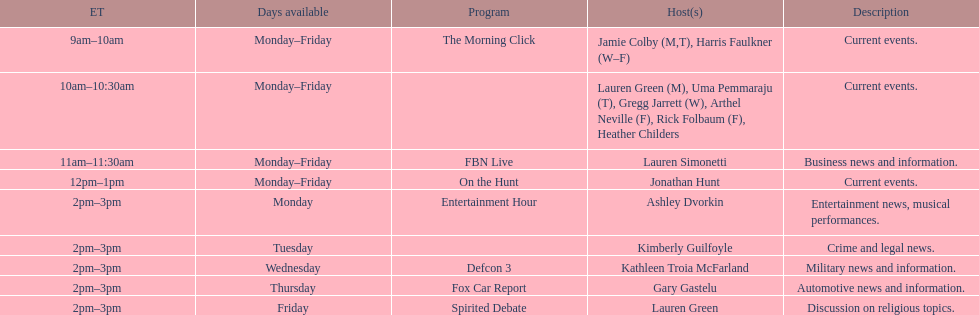Which program is only available on thursdays? Fox Car Report. 